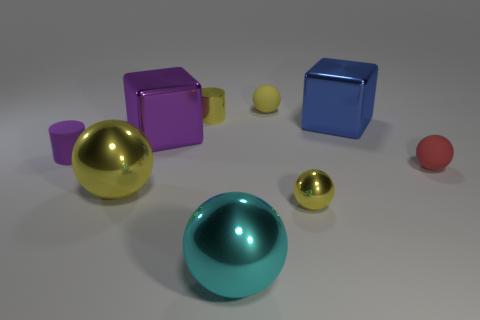Describe the surface on which the objects are placed; what material does it resemble? The surface appears to be a smooth, matte platform with a neutral gray color. It resembles a non-reflective, diffuse material, likely similar to a painted metal or a plastic with a fine texture to prevent glare. 